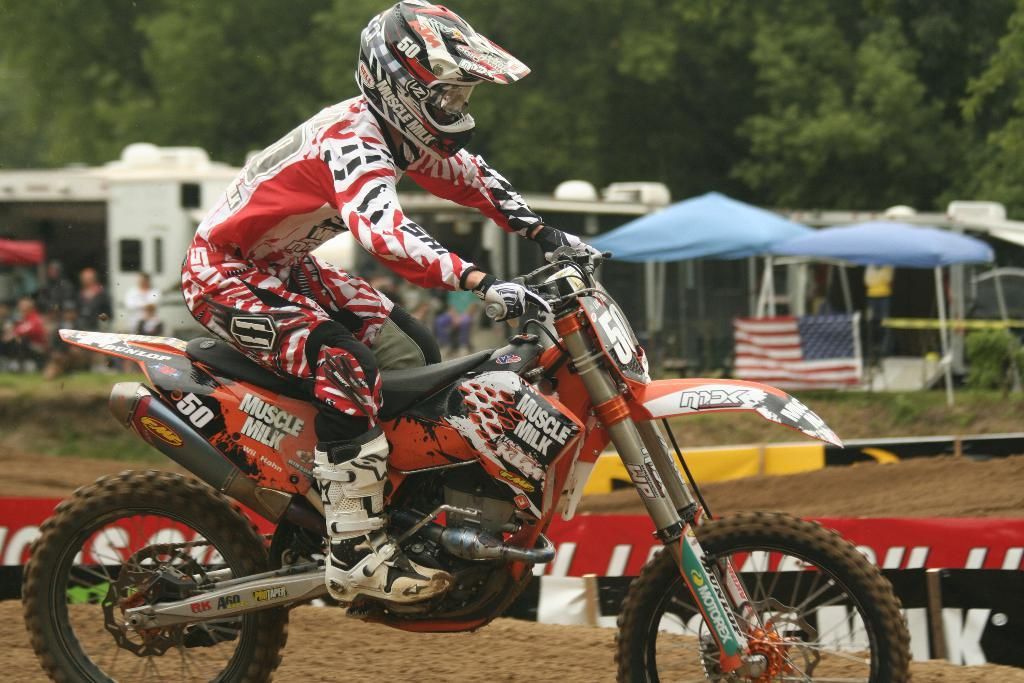What is the main activity of the person in the image? The person is riding a bike in the image. How is the bike positioned in the image? The bike is on the ground. What type of objects can be seen in the image besides the bike and the person? There are umbrellas, a flag, plants, grass, a shed, and other people in the image. What can be seen in the background of the image? There are trees in the background of the image. How many bags are being carried by the dogs in the image? There are no dogs present in the image, so it is not possible to determine how many bags they might be carrying. 